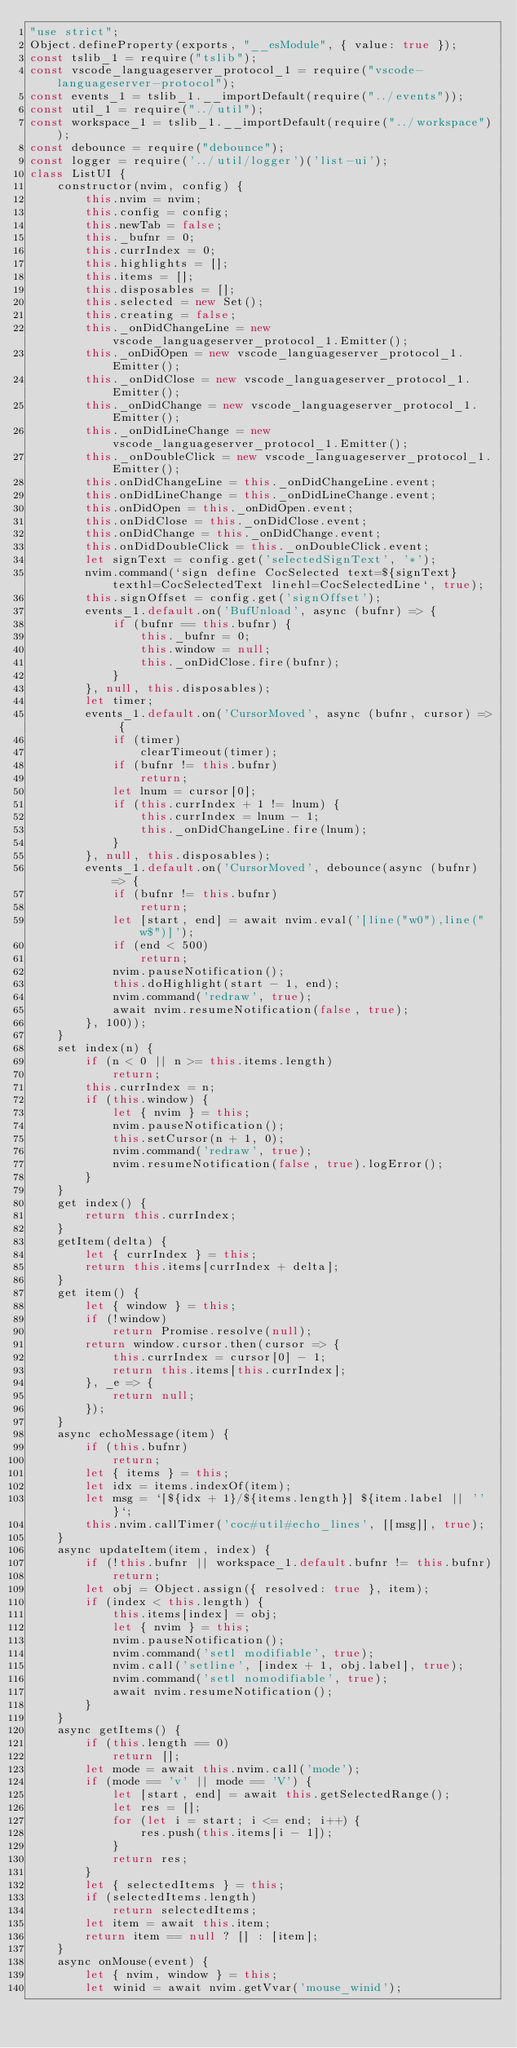<code> <loc_0><loc_0><loc_500><loc_500><_JavaScript_>"use strict";
Object.defineProperty(exports, "__esModule", { value: true });
const tslib_1 = require("tslib");
const vscode_languageserver_protocol_1 = require("vscode-languageserver-protocol");
const events_1 = tslib_1.__importDefault(require("../events"));
const util_1 = require("../util");
const workspace_1 = tslib_1.__importDefault(require("../workspace"));
const debounce = require("debounce");
const logger = require('../util/logger')('list-ui');
class ListUI {
    constructor(nvim, config) {
        this.nvim = nvim;
        this.config = config;
        this.newTab = false;
        this._bufnr = 0;
        this.currIndex = 0;
        this.highlights = [];
        this.items = [];
        this.disposables = [];
        this.selected = new Set();
        this.creating = false;
        this._onDidChangeLine = new vscode_languageserver_protocol_1.Emitter();
        this._onDidOpen = new vscode_languageserver_protocol_1.Emitter();
        this._onDidClose = new vscode_languageserver_protocol_1.Emitter();
        this._onDidChange = new vscode_languageserver_protocol_1.Emitter();
        this._onDidLineChange = new vscode_languageserver_protocol_1.Emitter();
        this._onDoubleClick = new vscode_languageserver_protocol_1.Emitter();
        this.onDidChangeLine = this._onDidChangeLine.event;
        this.onDidLineChange = this._onDidLineChange.event;
        this.onDidOpen = this._onDidOpen.event;
        this.onDidClose = this._onDidClose.event;
        this.onDidChange = this._onDidChange.event;
        this.onDidDoubleClick = this._onDoubleClick.event;
        let signText = config.get('selectedSignText', '*');
        nvim.command(`sign define CocSelected text=${signText} texthl=CocSelectedText linehl=CocSelectedLine`, true);
        this.signOffset = config.get('signOffset');
        events_1.default.on('BufUnload', async (bufnr) => {
            if (bufnr == this.bufnr) {
                this._bufnr = 0;
                this.window = null;
                this._onDidClose.fire(bufnr);
            }
        }, null, this.disposables);
        let timer;
        events_1.default.on('CursorMoved', async (bufnr, cursor) => {
            if (timer)
                clearTimeout(timer);
            if (bufnr != this.bufnr)
                return;
            let lnum = cursor[0];
            if (this.currIndex + 1 != lnum) {
                this.currIndex = lnum - 1;
                this._onDidChangeLine.fire(lnum);
            }
        }, null, this.disposables);
        events_1.default.on('CursorMoved', debounce(async (bufnr) => {
            if (bufnr != this.bufnr)
                return;
            let [start, end] = await nvim.eval('[line("w0"),line("w$")]');
            if (end < 500)
                return;
            nvim.pauseNotification();
            this.doHighlight(start - 1, end);
            nvim.command('redraw', true);
            await nvim.resumeNotification(false, true);
        }, 100));
    }
    set index(n) {
        if (n < 0 || n >= this.items.length)
            return;
        this.currIndex = n;
        if (this.window) {
            let { nvim } = this;
            nvim.pauseNotification();
            this.setCursor(n + 1, 0);
            nvim.command('redraw', true);
            nvim.resumeNotification(false, true).logError();
        }
    }
    get index() {
        return this.currIndex;
    }
    getItem(delta) {
        let { currIndex } = this;
        return this.items[currIndex + delta];
    }
    get item() {
        let { window } = this;
        if (!window)
            return Promise.resolve(null);
        return window.cursor.then(cursor => {
            this.currIndex = cursor[0] - 1;
            return this.items[this.currIndex];
        }, _e => {
            return null;
        });
    }
    async echoMessage(item) {
        if (this.bufnr)
            return;
        let { items } = this;
        let idx = items.indexOf(item);
        let msg = `[${idx + 1}/${items.length}] ${item.label || ''}`;
        this.nvim.callTimer('coc#util#echo_lines', [[msg]], true);
    }
    async updateItem(item, index) {
        if (!this.bufnr || workspace_1.default.bufnr != this.bufnr)
            return;
        let obj = Object.assign({ resolved: true }, item);
        if (index < this.length) {
            this.items[index] = obj;
            let { nvim } = this;
            nvim.pauseNotification();
            nvim.command('setl modifiable', true);
            nvim.call('setline', [index + 1, obj.label], true);
            nvim.command('setl nomodifiable', true);
            await nvim.resumeNotification();
        }
    }
    async getItems() {
        if (this.length == 0)
            return [];
        let mode = await this.nvim.call('mode');
        if (mode == 'v' || mode == 'V') {
            let [start, end] = await this.getSelectedRange();
            let res = [];
            for (let i = start; i <= end; i++) {
                res.push(this.items[i - 1]);
            }
            return res;
        }
        let { selectedItems } = this;
        if (selectedItems.length)
            return selectedItems;
        let item = await this.item;
        return item == null ? [] : [item];
    }
    async onMouse(event) {
        let { nvim, window } = this;
        let winid = await nvim.getVvar('mouse_winid');</code> 